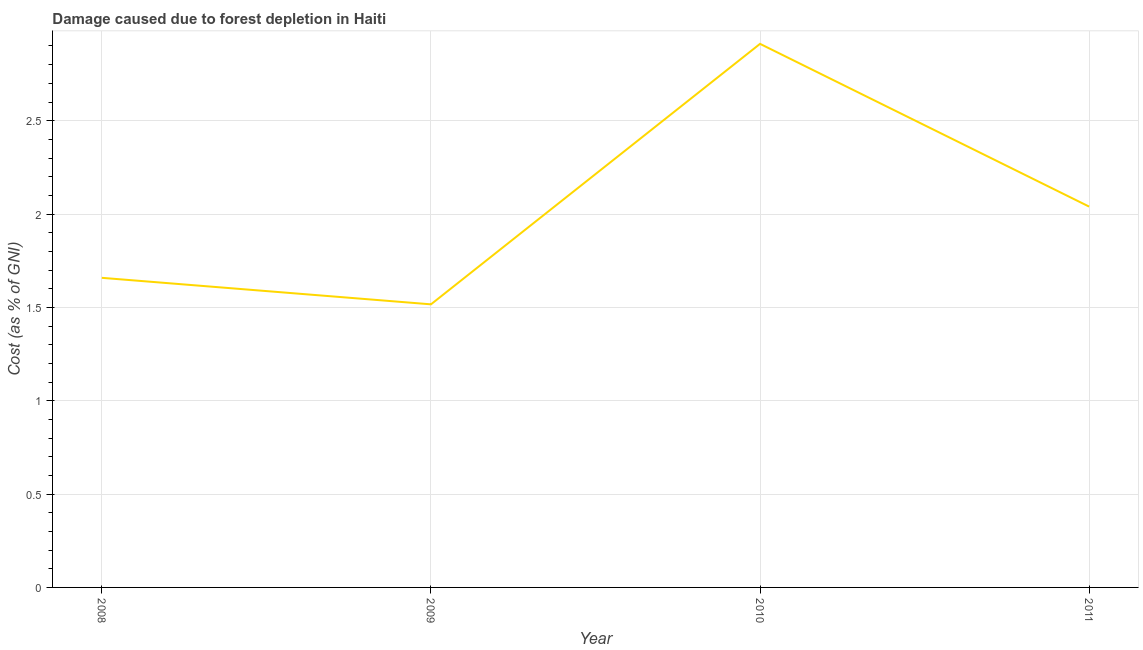What is the damage caused due to forest depletion in 2010?
Give a very brief answer. 2.91. Across all years, what is the maximum damage caused due to forest depletion?
Provide a short and direct response. 2.91. Across all years, what is the minimum damage caused due to forest depletion?
Offer a very short reply. 1.52. What is the sum of the damage caused due to forest depletion?
Provide a short and direct response. 8.13. What is the difference between the damage caused due to forest depletion in 2008 and 2009?
Your answer should be very brief. 0.14. What is the average damage caused due to forest depletion per year?
Make the answer very short. 2.03. What is the median damage caused due to forest depletion?
Keep it short and to the point. 1.85. What is the ratio of the damage caused due to forest depletion in 2009 to that in 2010?
Provide a succinct answer. 0.52. Is the damage caused due to forest depletion in 2008 less than that in 2010?
Offer a very short reply. Yes. Is the difference between the damage caused due to forest depletion in 2009 and 2010 greater than the difference between any two years?
Keep it short and to the point. Yes. What is the difference between the highest and the second highest damage caused due to forest depletion?
Provide a short and direct response. 0.87. Is the sum of the damage caused due to forest depletion in 2008 and 2010 greater than the maximum damage caused due to forest depletion across all years?
Offer a terse response. Yes. What is the difference between the highest and the lowest damage caused due to forest depletion?
Keep it short and to the point. 1.4. In how many years, is the damage caused due to forest depletion greater than the average damage caused due to forest depletion taken over all years?
Offer a very short reply. 2. Are the values on the major ticks of Y-axis written in scientific E-notation?
Keep it short and to the point. No. Does the graph contain grids?
Your response must be concise. Yes. What is the title of the graph?
Offer a very short reply. Damage caused due to forest depletion in Haiti. What is the label or title of the Y-axis?
Your answer should be very brief. Cost (as % of GNI). What is the Cost (as % of GNI) in 2008?
Provide a succinct answer. 1.66. What is the Cost (as % of GNI) of 2009?
Provide a succinct answer. 1.52. What is the Cost (as % of GNI) of 2010?
Offer a very short reply. 2.91. What is the Cost (as % of GNI) in 2011?
Provide a short and direct response. 2.04. What is the difference between the Cost (as % of GNI) in 2008 and 2009?
Ensure brevity in your answer.  0.14. What is the difference between the Cost (as % of GNI) in 2008 and 2010?
Provide a short and direct response. -1.25. What is the difference between the Cost (as % of GNI) in 2008 and 2011?
Offer a terse response. -0.38. What is the difference between the Cost (as % of GNI) in 2009 and 2010?
Your response must be concise. -1.4. What is the difference between the Cost (as % of GNI) in 2009 and 2011?
Your answer should be very brief. -0.52. What is the difference between the Cost (as % of GNI) in 2010 and 2011?
Your response must be concise. 0.87. What is the ratio of the Cost (as % of GNI) in 2008 to that in 2009?
Ensure brevity in your answer.  1.09. What is the ratio of the Cost (as % of GNI) in 2008 to that in 2010?
Your answer should be very brief. 0.57. What is the ratio of the Cost (as % of GNI) in 2008 to that in 2011?
Offer a very short reply. 0.81. What is the ratio of the Cost (as % of GNI) in 2009 to that in 2010?
Offer a very short reply. 0.52. What is the ratio of the Cost (as % of GNI) in 2009 to that in 2011?
Ensure brevity in your answer.  0.74. What is the ratio of the Cost (as % of GNI) in 2010 to that in 2011?
Offer a very short reply. 1.43. 